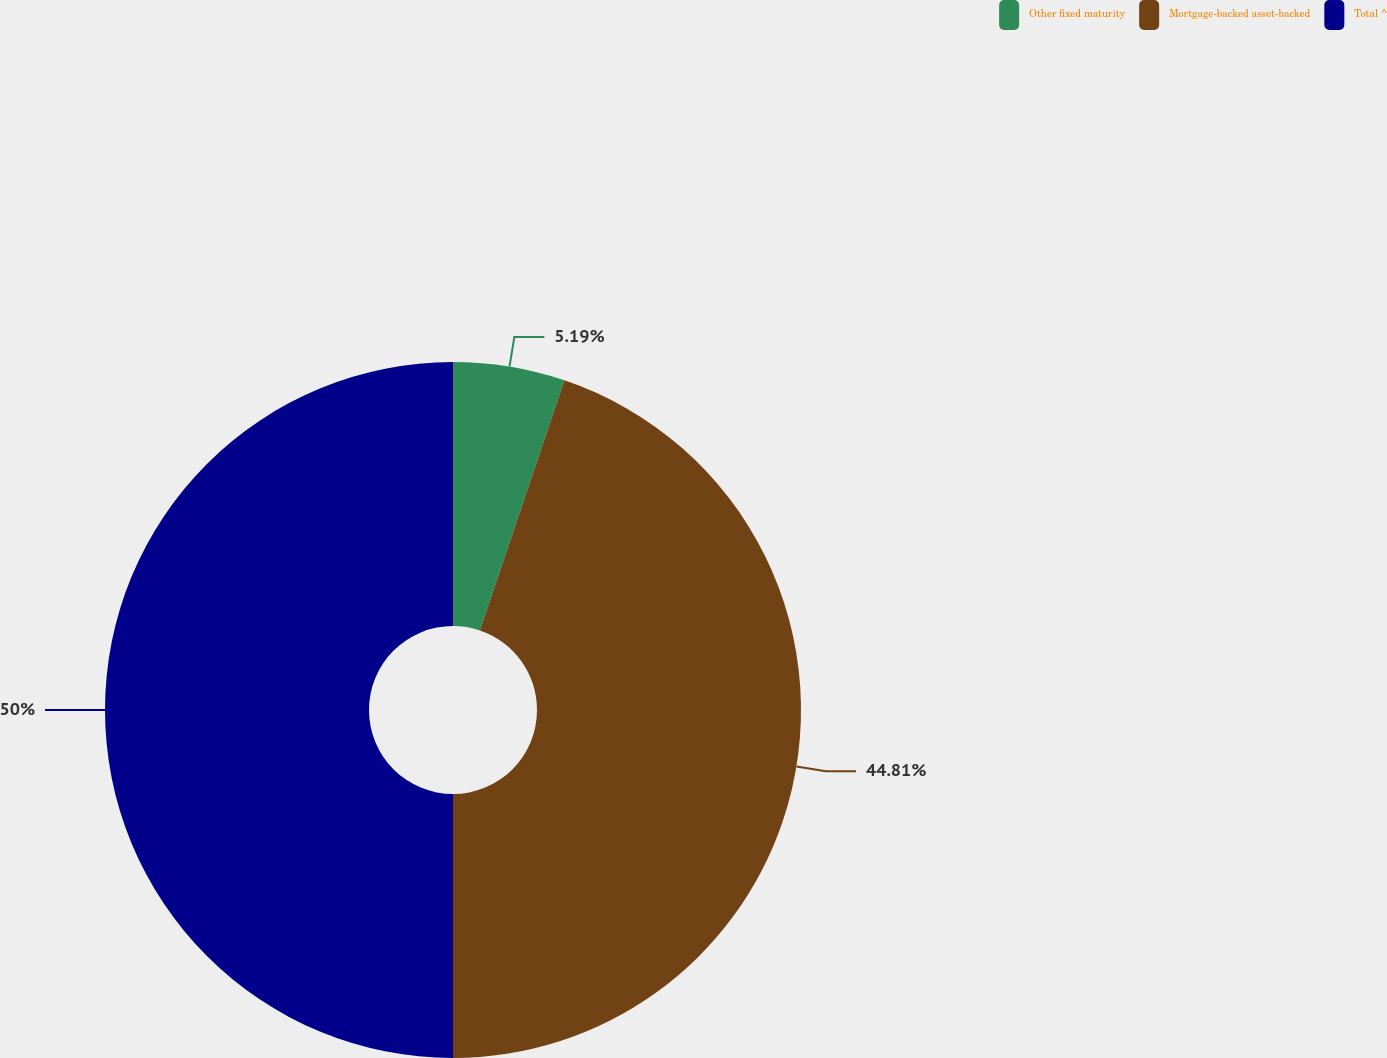<chart> <loc_0><loc_0><loc_500><loc_500><pie_chart><fcel>Other fixed maturity<fcel>Mortgage-backed asset-backed<fcel>Total ^<nl><fcel>5.19%<fcel>44.81%<fcel>50.0%<nl></chart> 